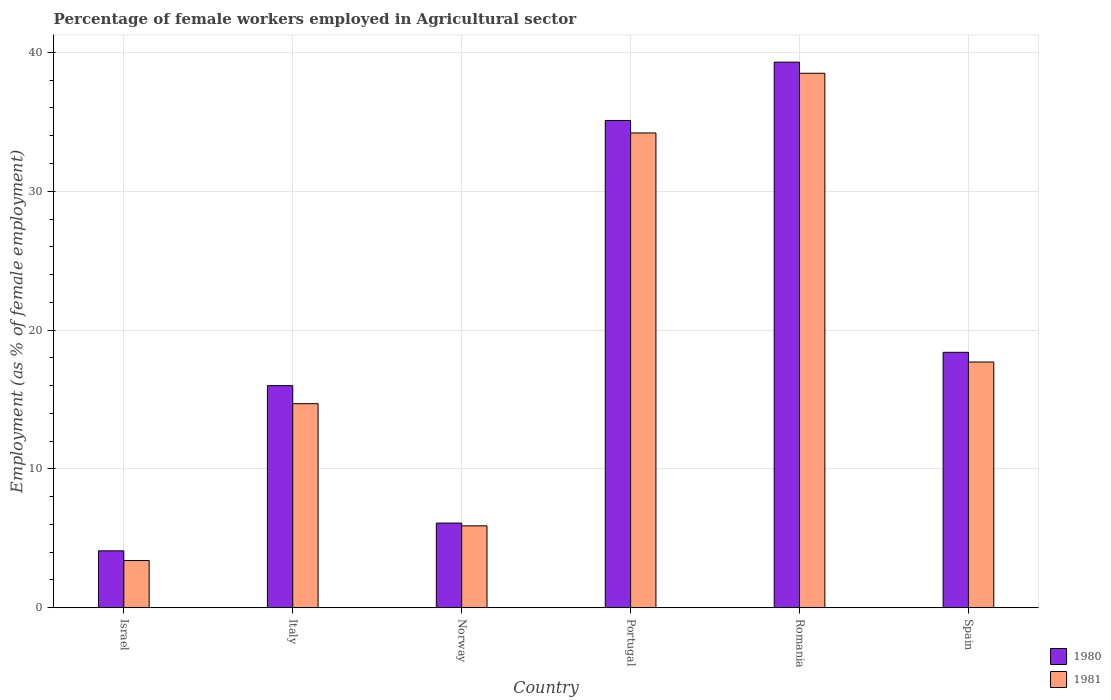How many different coloured bars are there?
Give a very brief answer. 2. Are the number of bars on each tick of the X-axis equal?
Your answer should be compact. Yes. How many bars are there on the 2nd tick from the right?
Keep it short and to the point. 2. What is the percentage of females employed in Agricultural sector in 1981 in Portugal?
Your answer should be very brief. 34.2. Across all countries, what is the maximum percentage of females employed in Agricultural sector in 1981?
Keep it short and to the point. 38.5. Across all countries, what is the minimum percentage of females employed in Agricultural sector in 1981?
Provide a short and direct response. 3.4. In which country was the percentage of females employed in Agricultural sector in 1981 maximum?
Ensure brevity in your answer.  Romania. In which country was the percentage of females employed in Agricultural sector in 1980 minimum?
Your response must be concise. Israel. What is the total percentage of females employed in Agricultural sector in 1980 in the graph?
Offer a very short reply. 119. What is the difference between the percentage of females employed in Agricultural sector in 1981 in Israel and that in Portugal?
Provide a succinct answer. -30.8. What is the difference between the percentage of females employed in Agricultural sector in 1980 in Portugal and the percentage of females employed in Agricultural sector in 1981 in Spain?
Your answer should be compact. 17.4. What is the average percentage of females employed in Agricultural sector in 1981 per country?
Your response must be concise. 19.07. What is the difference between the percentage of females employed in Agricultural sector of/in 1981 and percentage of females employed in Agricultural sector of/in 1980 in Norway?
Make the answer very short. -0.2. What is the ratio of the percentage of females employed in Agricultural sector in 1980 in Israel to that in Italy?
Your answer should be compact. 0.26. Is the percentage of females employed in Agricultural sector in 1980 in Norway less than that in Portugal?
Offer a very short reply. Yes. What is the difference between the highest and the second highest percentage of females employed in Agricultural sector in 1981?
Provide a short and direct response. -16.5. What is the difference between the highest and the lowest percentage of females employed in Agricultural sector in 1980?
Your response must be concise. 35.2. In how many countries, is the percentage of females employed in Agricultural sector in 1981 greater than the average percentage of females employed in Agricultural sector in 1981 taken over all countries?
Make the answer very short. 2. What does the 2nd bar from the left in Israel represents?
Your response must be concise. 1981. What does the 2nd bar from the right in Spain represents?
Your answer should be compact. 1980. How many bars are there?
Keep it short and to the point. 12. How many countries are there in the graph?
Offer a terse response. 6. Does the graph contain any zero values?
Provide a succinct answer. No. Where does the legend appear in the graph?
Give a very brief answer. Bottom right. How are the legend labels stacked?
Offer a terse response. Vertical. What is the title of the graph?
Your answer should be compact. Percentage of female workers employed in Agricultural sector. Does "2004" appear as one of the legend labels in the graph?
Give a very brief answer. No. What is the label or title of the Y-axis?
Your answer should be compact. Employment (as % of female employment). What is the Employment (as % of female employment) of 1980 in Israel?
Ensure brevity in your answer.  4.1. What is the Employment (as % of female employment) of 1981 in Israel?
Offer a terse response. 3.4. What is the Employment (as % of female employment) of 1980 in Italy?
Ensure brevity in your answer.  16. What is the Employment (as % of female employment) in 1981 in Italy?
Ensure brevity in your answer.  14.7. What is the Employment (as % of female employment) of 1980 in Norway?
Provide a short and direct response. 6.1. What is the Employment (as % of female employment) in 1981 in Norway?
Your answer should be compact. 5.9. What is the Employment (as % of female employment) in 1980 in Portugal?
Your answer should be very brief. 35.1. What is the Employment (as % of female employment) in 1981 in Portugal?
Offer a terse response. 34.2. What is the Employment (as % of female employment) of 1980 in Romania?
Provide a succinct answer. 39.3. What is the Employment (as % of female employment) of 1981 in Romania?
Keep it short and to the point. 38.5. What is the Employment (as % of female employment) of 1980 in Spain?
Ensure brevity in your answer.  18.4. What is the Employment (as % of female employment) in 1981 in Spain?
Your response must be concise. 17.7. Across all countries, what is the maximum Employment (as % of female employment) in 1980?
Provide a succinct answer. 39.3. Across all countries, what is the maximum Employment (as % of female employment) in 1981?
Your response must be concise. 38.5. Across all countries, what is the minimum Employment (as % of female employment) in 1980?
Your answer should be compact. 4.1. Across all countries, what is the minimum Employment (as % of female employment) in 1981?
Ensure brevity in your answer.  3.4. What is the total Employment (as % of female employment) of 1980 in the graph?
Provide a short and direct response. 119. What is the total Employment (as % of female employment) in 1981 in the graph?
Offer a very short reply. 114.4. What is the difference between the Employment (as % of female employment) of 1980 in Israel and that in Italy?
Offer a terse response. -11.9. What is the difference between the Employment (as % of female employment) of 1981 in Israel and that in Italy?
Ensure brevity in your answer.  -11.3. What is the difference between the Employment (as % of female employment) of 1980 in Israel and that in Norway?
Your response must be concise. -2. What is the difference between the Employment (as % of female employment) of 1981 in Israel and that in Norway?
Offer a very short reply. -2.5. What is the difference between the Employment (as % of female employment) of 1980 in Israel and that in Portugal?
Offer a very short reply. -31. What is the difference between the Employment (as % of female employment) in 1981 in Israel and that in Portugal?
Your answer should be very brief. -30.8. What is the difference between the Employment (as % of female employment) of 1980 in Israel and that in Romania?
Your answer should be very brief. -35.2. What is the difference between the Employment (as % of female employment) of 1981 in Israel and that in Romania?
Your answer should be compact. -35.1. What is the difference between the Employment (as % of female employment) in 1980 in Israel and that in Spain?
Your response must be concise. -14.3. What is the difference between the Employment (as % of female employment) in 1981 in Israel and that in Spain?
Your answer should be very brief. -14.3. What is the difference between the Employment (as % of female employment) of 1980 in Italy and that in Norway?
Offer a very short reply. 9.9. What is the difference between the Employment (as % of female employment) of 1981 in Italy and that in Norway?
Your answer should be compact. 8.8. What is the difference between the Employment (as % of female employment) of 1980 in Italy and that in Portugal?
Keep it short and to the point. -19.1. What is the difference between the Employment (as % of female employment) of 1981 in Italy and that in Portugal?
Your answer should be compact. -19.5. What is the difference between the Employment (as % of female employment) in 1980 in Italy and that in Romania?
Provide a succinct answer. -23.3. What is the difference between the Employment (as % of female employment) in 1981 in Italy and that in Romania?
Ensure brevity in your answer.  -23.8. What is the difference between the Employment (as % of female employment) in 1980 in Norway and that in Portugal?
Provide a succinct answer. -29. What is the difference between the Employment (as % of female employment) of 1981 in Norway and that in Portugal?
Keep it short and to the point. -28.3. What is the difference between the Employment (as % of female employment) of 1980 in Norway and that in Romania?
Keep it short and to the point. -33.2. What is the difference between the Employment (as % of female employment) of 1981 in Norway and that in Romania?
Give a very brief answer. -32.6. What is the difference between the Employment (as % of female employment) in 1980 in Norway and that in Spain?
Offer a terse response. -12.3. What is the difference between the Employment (as % of female employment) in 1981 in Portugal and that in Romania?
Ensure brevity in your answer.  -4.3. What is the difference between the Employment (as % of female employment) of 1980 in Portugal and that in Spain?
Give a very brief answer. 16.7. What is the difference between the Employment (as % of female employment) in 1980 in Romania and that in Spain?
Your response must be concise. 20.9. What is the difference between the Employment (as % of female employment) in 1981 in Romania and that in Spain?
Your answer should be compact. 20.8. What is the difference between the Employment (as % of female employment) in 1980 in Israel and the Employment (as % of female employment) in 1981 in Italy?
Your answer should be compact. -10.6. What is the difference between the Employment (as % of female employment) of 1980 in Israel and the Employment (as % of female employment) of 1981 in Norway?
Your answer should be compact. -1.8. What is the difference between the Employment (as % of female employment) of 1980 in Israel and the Employment (as % of female employment) of 1981 in Portugal?
Offer a terse response. -30.1. What is the difference between the Employment (as % of female employment) in 1980 in Israel and the Employment (as % of female employment) in 1981 in Romania?
Provide a short and direct response. -34.4. What is the difference between the Employment (as % of female employment) of 1980 in Israel and the Employment (as % of female employment) of 1981 in Spain?
Give a very brief answer. -13.6. What is the difference between the Employment (as % of female employment) of 1980 in Italy and the Employment (as % of female employment) of 1981 in Norway?
Keep it short and to the point. 10.1. What is the difference between the Employment (as % of female employment) in 1980 in Italy and the Employment (as % of female employment) in 1981 in Portugal?
Your answer should be compact. -18.2. What is the difference between the Employment (as % of female employment) in 1980 in Italy and the Employment (as % of female employment) in 1981 in Romania?
Provide a succinct answer. -22.5. What is the difference between the Employment (as % of female employment) in 1980 in Italy and the Employment (as % of female employment) in 1981 in Spain?
Provide a short and direct response. -1.7. What is the difference between the Employment (as % of female employment) in 1980 in Norway and the Employment (as % of female employment) in 1981 in Portugal?
Make the answer very short. -28.1. What is the difference between the Employment (as % of female employment) in 1980 in Norway and the Employment (as % of female employment) in 1981 in Romania?
Your answer should be very brief. -32.4. What is the difference between the Employment (as % of female employment) in 1980 in Norway and the Employment (as % of female employment) in 1981 in Spain?
Your response must be concise. -11.6. What is the difference between the Employment (as % of female employment) in 1980 in Portugal and the Employment (as % of female employment) in 1981 in Romania?
Offer a very short reply. -3.4. What is the difference between the Employment (as % of female employment) of 1980 in Romania and the Employment (as % of female employment) of 1981 in Spain?
Provide a succinct answer. 21.6. What is the average Employment (as % of female employment) in 1980 per country?
Provide a short and direct response. 19.83. What is the average Employment (as % of female employment) in 1981 per country?
Provide a succinct answer. 19.07. What is the difference between the Employment (as % of female employment) in 1980 and Employment (as % of female employment) in 1981 in Norway?
Your answer should be compact. 0.2. What is the ratio of the Employment (as % of female employment) in 1980 in Israel to that in Italy?
Your answer should be compact. 0.26. What is the ratio of the Employment (as % of female employment) in 1981 in Israel to that in Italy?
Your answer should be very brief. 0.23. What is the ratio of the Employment (as % of female employment) in 1980 in Israel to that in Norway?
Offer a very short reply. 0.67. What is the ratio of the Employment (as % of female employment) of 1981 in Israel to that in Norway?
Your answer should be very brief. 0.58. What is the ratio of the Employment (as % of female employment) of 1980 in Israel to that in Portugal?
Keep it short and to the point. 0.12. What is the ratio of the Employment (as % of female employment) of 1981 in Israel to that in Portugal?
Offer a very short reply. 0.1. What is the ratio of the Employment (as % of female employment) of 1980 in Israel to that in Romania?
Your response must be concise. 0.1. What is the ratio of the Employment (as % of female employment) of 1981 in Israel to that in Romania?
Offer a very short reply. 0.09. What is the ratio of the Employment (as % of female employment) of 1980 in Israel to that in Spain?
Offer a terse response. 0.22. What is the ratio of the Employment (as % of female employment) in 1981 in Israel to that in Spain?
Your answer should be very brief. 0.19. What is the ratio of the Employment (as % of female employment) in 1980 in Italy to that in Norway?
Make the answer very short. 2.62. What is the ratio of the Employment (as % of female employment) in 1981 in Italy to that in Norway?
Provide a succinct answer. 2.49. What is the ratio of the Employment (as % of female employment) in 1980 in Italy to that in Portugal?
Provide a succinct answer. 0.46. What is the ratio of the Employment (as % of female employment) in 1981 in Italy to that in Portugal?
Give a very brief answer. 0.43. What is the ratio of the Employment (as % of female employment) of 1980 in Italy to that in Romania?
Your answer should be very brief. 0.41. What is the ratio of the Employment (as % of female employment) in 1981 in Italy to that in Romania?
Provide a short and direct response. 0.38. What is the ratio of the Employment (as % of female employment) of 1980 in Italy to that in Spain?
Keep it short and to the point. 0.87. What is the ratio of the Employment (as % of female employment) of 1981 in Italy to that in Spain?
Your response must be concise. 0.83. What is the ratio of the Employment (as % of female employment) of 1980 in Norway to that in Portugal?
Make the answer very short. 0.17. What is the ratio of the Employment (as % of female employment) of 1981 in Norway to that in Portugal?
Your answer should be compact. 0.17. What is the ratio of the Employment (as % of female employment) of 1980 in Norway to that in Romania?
Keep it short and to the point. 0.16. What is the ratio of the Employment (as % of female employment) in 1981 in Norway to that in Romania?
Ensure brevity in your answer.  0.15. What is the ratio of the Employment (as % of female employment) in 1980 in Norway to that in Spain?
Your answer should be compact. 0.33. What is the ratio of the Employment (as % of female employment) of 1980 in Portugal to that in Romania?
Your answer should be compact. 0.89. What is the ratio of the Employment (as % of female employment) of 1981 in Portugal to that in Romania?
Offer a very short reply. 0.89. What is the ratio of the Employment (as % of female employment) of 1980 in Portugal to that in Spain?
Provide a succinct answer. 1.91. What is the ratio of the Employment (as % of female employment) of 1981 in Portugal to that in Spain?
Make the answer very short. 1.93. What is the ratio of the Employment (as % of female employment) in 1980 in Romania to that in Spain?
Provide a short and direct response. 2.14. What is the ratio of the Employment (as % of female employment) of 1981 in Romania to that in Spain?
Provide a succinct answer. 2.18. What is the difference between the highest and the second highest Employment (as % of female employment) of 1980?
Your response must be concise. 4.2. What is the difference between the highest and the second highest Employment (as % of female employment) of 1981?
Provide a succinct answer. 4.3. What is the difference between the highest and the lowest Employment (as % of female employment) in 1980?
Keep it short and to the point. 35.2. What is the difference between the highest and the lowest Employment (as % of female employment) of 1981?
Make the answer very short. 35.1. 